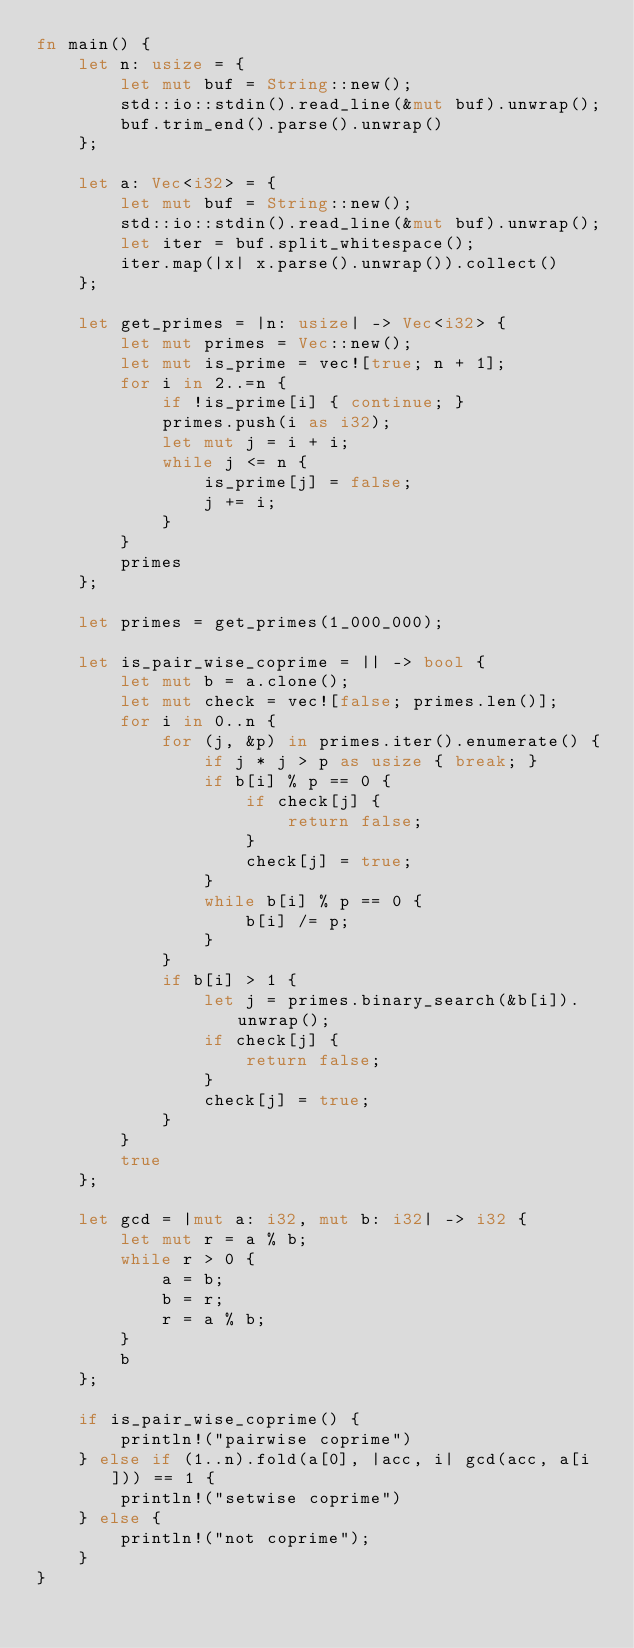<code> <loc_0><loc_0><loc_500><loc_500><_Rust_>fn main() {
    let n: usize = {
        let mut buf = String::new();
        std::io::stdin().read_line(&mut buf).unwrap();
        buf.trim_end().parse().unwrap()
    };

    let a: Vec<i32> = {
        let mut buf = String::new();
        std::io::stdin().read_line(&mut buf).unwrap();
        let iter = buf.split_whitespace();
        iter.map(|x| x.parse().unwrap()).collect()
    };

    let get_primes = |n: usize| -> Vec<i32> {
        let mut primes = Vec::new();
        let mut is_prime = vec![true; n + 1];
        for i in 2..=n {
            if !is_prime[i] { continue; }
            primes.push(i as i32);
            let mut j = i + i;
            while j <= n {
                is_prime[j] = false;
                j += i;
            }
        }
        primes
    };

    let primes = get_primes(1_000_000);

    let is_pair_wise_coprime = || -> bool {
        let mut b = a.clone();
        let mut check = vec![false; primes.len()];
        for i in 0..n {
            for (j, &p) in primes.iter().enumerate() {
                if j * j > p as usize { break; }
                if b[i] % p == 0 {
                    if check[j] {
                        return false;
                    }
                    check[j] = true;
                }
                while b[i] % p == 0 {
                    b[i] /= p;
                }
            }
            if b[i] > 1 {
                let j = primes.binary_search(&b[i]).unwrap();
                if check[j] {
                    return false;
                }
                check[j] = true;
            }
        }
        true
    };

    let gcd = |mut a: i32, mut b: i32| -> i32 {
        let mut r = a % b;
        while r > 0 {
            a = b;
            b = r;
            r = a % b;
        }
        b
    };

    if is_pair_wise_coprime() {
        println!("pairwise coprime")
    } else if (1..n).fold(a[0], |acc, i| gcd(acc, a[i])) == 1 {
        println!("setwise coprime")
    } else {
        println!("not coprime");
    }
}</code> 